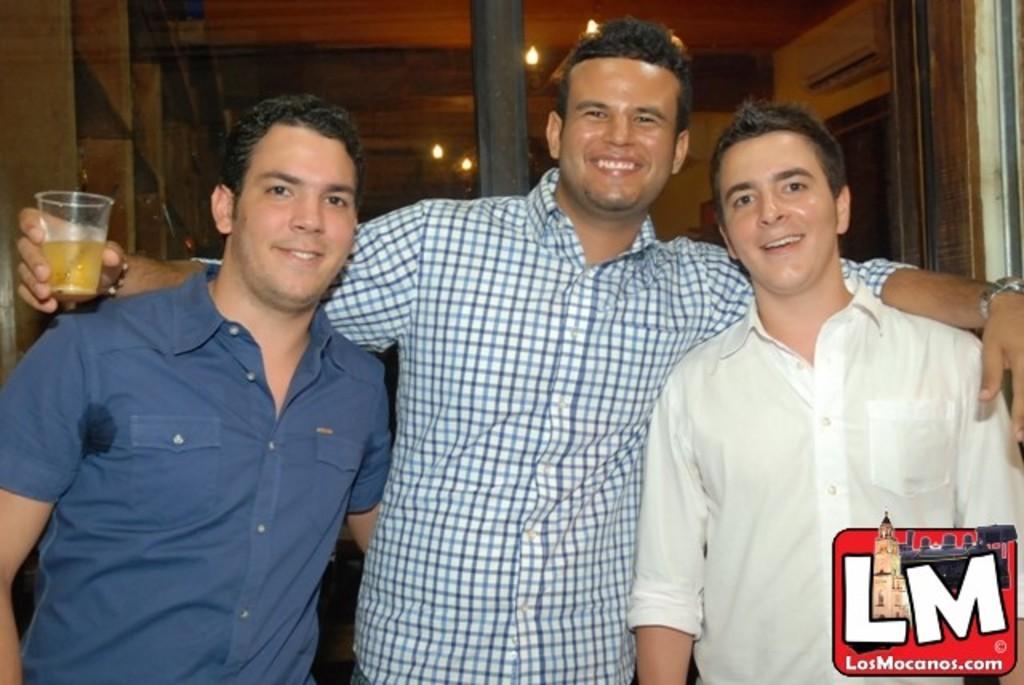In one or two sentences, can you explain what this image depicts? In this picture I can see there are three men standing and they are wearing shirts, the person at center is holding a glass and there is a sliding in the backdrop and it has a glass attached to the door. There are lights attached to the ceiling and there are few shelves at left side. 